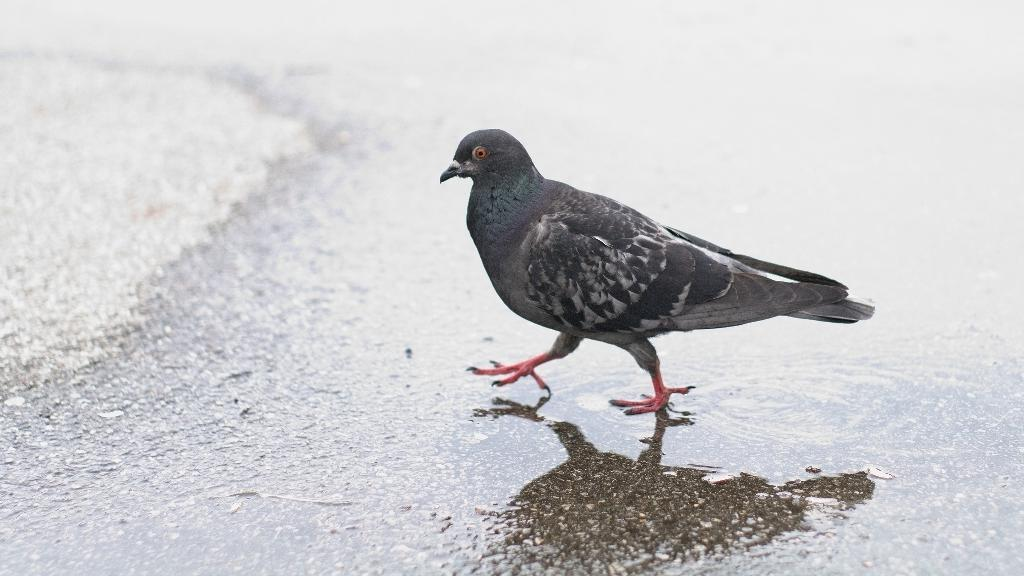What type of animal is in the image? There is a pigeon in the image. What is the pigeon doing in the image? The pigeon is walking. What is the condition of the road in the image? The road is wet. How many legs does the bedroom have in the image? There is no bedroom present in the image, so it is not possible to determine how many legs it might have. 